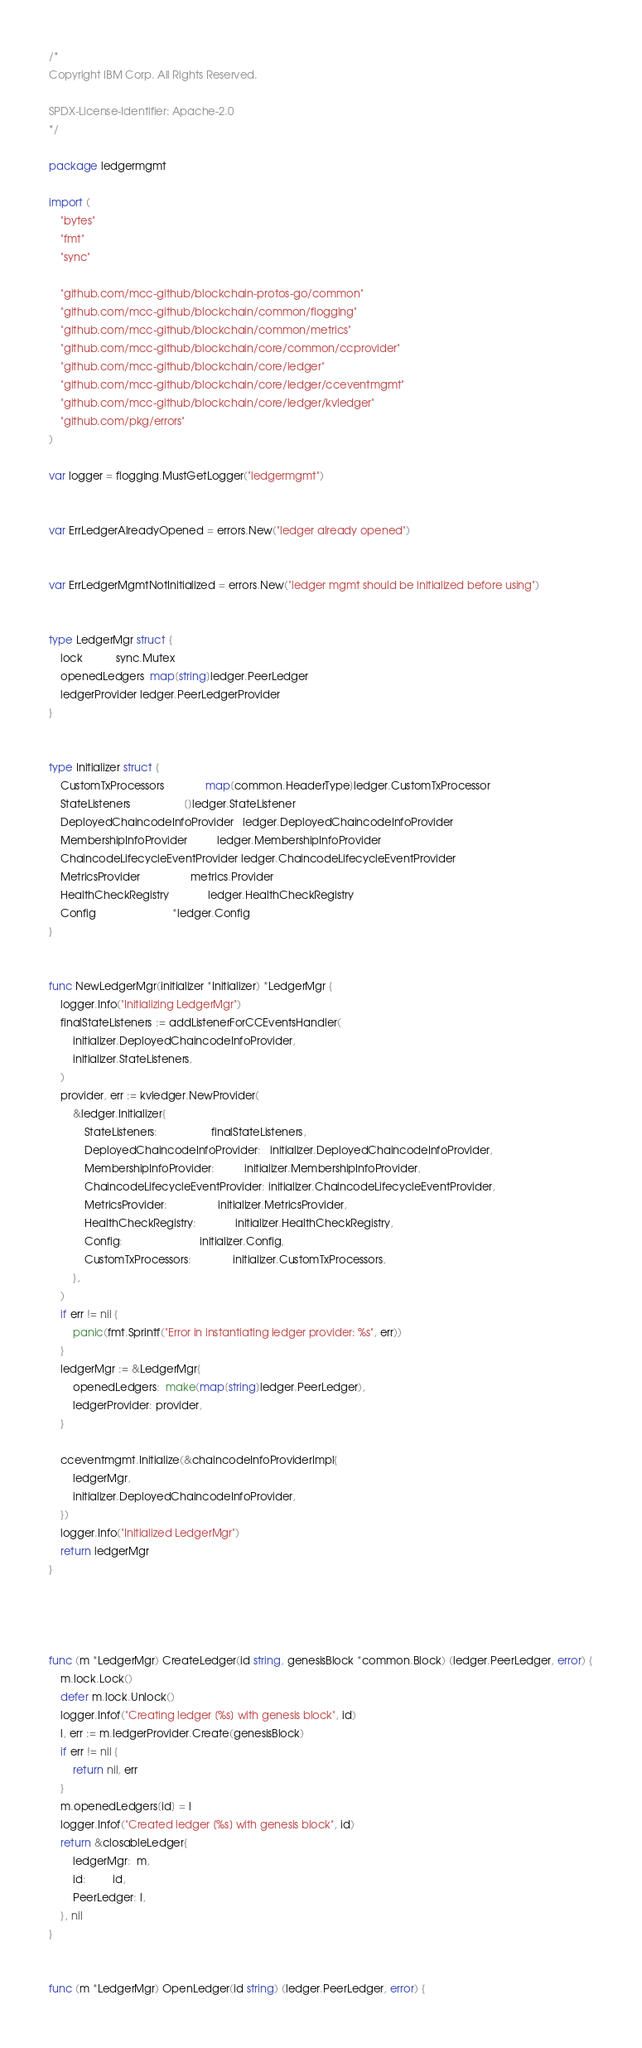Convert code to text. <code><loc_0><loc_0><loc_500><loc_500><_Go_>/*
Copyright IBM Corp. All Rights Reserved.

SPDX-License-Identifier: Apache-2.0
*/

package ledgermgmt

import (
	"bytes"
	"fmt"
	"sync"

	"github.com/mcc-github/blockchain-protos-go/common"
	"github.com/mcc-github/blockchain/common/flogging"
	"github.com/mcc-github/blockchain/common/metrics"
	"github.com/mcc-github/blockchain/core/common/ccprovider"
	"github.com/mcc-github/blockchain/core/ledger"
	"github.com/mcc-github/blockchain/core/ledger/cceventmgmt"
	"github.com/mcc-github/blockchain/core/ledger/kvledger"
	"github.com/pkg/errors"
)

var logger = flogging.MustGetLogger("ledgermgmt")


var ErrLedgerAlreadyOpened = errors.New("ledger already opened")


var ErrLedgerMgmtNotInitialized = errors.New("ledger mgmt should be initialized before using")


type LedgerMgr struct {
	lock           sync.Mutex
	openedLedgers  map[string]ledger.PeerLedger
	ledgerProvider ledger.PeerLedgerProvider
}


type Initializer struct {
	CustomTxProcessors              map[common.HeaderType]ledger.CustomTxProcessor
	StateListeners                  []ledger.StateListener
	DeployedChaincodeInfoProvider   ledger.DeployedChaincodeInfoProvider
	MembershipInfoProvider          ledger.MembershipInfoProvider
	ChaincodeLifecycleEventProvider ledger.ChaincodeLifecycleEventProvider
	MetricsProvider                 metrics.Provider
	HealthCheckRegistry             ledger.HealthCheckRegistry
	Config                          *ledger.Config
}


func NewLedgerMgr(initializer *Initializer) *LedgerMgr {
	logger.Info("Initializing LedgerMgr")
	finalStateListeners := addListenerForCCEventsHandler(
		initializer.DeployedChaincodeInfoProvider,
		initializer.StateListeners,
	)
	provider, err := kvledger.NewProvider(
		&ledger.Initializer{
			StateListeners:                  finalStateListeners,
			DeployedChaincodeInfoProvider:   initializer.DeployedChaincodeInfoProvider,
			MembershipInfoProvider:          initializer.MembershipInfoProvider,
			ChaincodeLifecycleEventProvider: initializer.ChaincodeLifecycleEventProvider,
			MetricsProvider:                 initializer.MetricsProvider,
			HealthCheckRegistry:             initializer.HealthCheckRegistry,
			Config:                          initializer.Config,
			CustomTxProcessors:              initializer.CustomTxProcessors,
		},
	)
	if err != nil {
		panic(fmt.Sprintf("Error in instantiating ledger provider: %s", err))
	}
	ledgerMgr := &LedgerMgr{
		openedLedgers:  make(map[string]ledger.PeerLedger),
		ledgerProvider: provider,
	}
	
	cceventmgmt.Initialize(&chaincodeInfoProviderImpl{
		ledgerMgr,
		initializer.DeployedChaincodeInfoProvider,
	})
	logger.Info("Initialized LedgerMgr")
	return ledgerMgr
}




func (m *LedgerMgr) CreateLedger(id string, genesisBlock *common.Block) (ledger.PeerLedger, error) {
	m.lock.Lock()
	defer m.lock.Unlock()
	logger.Infof("Creating ledger [%s] with genesis block", id)
	l, err := m.ledgerProvider.Create(genesisBlock)
	if err != nil {
		return nil, err
	}
	m.openedLedgers[id] = l
	logger.Infof("Created ledger [%s] with genesis block", id)
	return &closableLedger{
		ledgerMgr:  m,
		id:         id,
		PeerLedger: l,
	}, nil
}


func (m *LedgerMgr) OpenLedger(id string) (ledger.PeerLedger, error) {</code> 